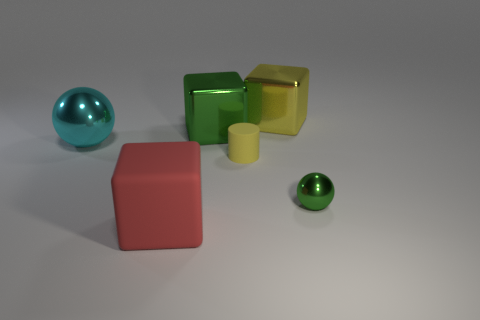There is a yellow object that is the same shape as the large red object; what is its size?
Make the answer very short. Large. The tiny thing that is the same shape as the large cyan metal thing is what color?
Your answer should be very brief. Green. Is the thing left of the red matte cube made of the same material as the yellow cylinder?
Provide a succinct answer. No. What shape is the green metallic object behind the big thing on the left side of the large cube in front of the green metallic block?
Offer a very short reply. Cube. Are there the same number of shiny spheres that are to the left of the big yellow object and large matte cubes that are behind the tiny green object?
Your answer should be very brief. No. What is the color of the sphere that is the same size as the yellow rubber cylinder?
Ensure brevity in your answer.  Green. How many tiny objects are red rubber things or cyan balls?
Keep it short and to the point. 0. What is the material of the object that is on the right side of the yellow rubber object and behind the big shiny ball?
Your response must be concise. Metal. Is the shape of the yellow object that is on the right side of the yellow rubber object the same as the rubber thing in front of the small shiny sphere?
Make the answer very short. Yes. The large object that is the same color as the small sphere is what shape?
Your response must be concise. Cube. 